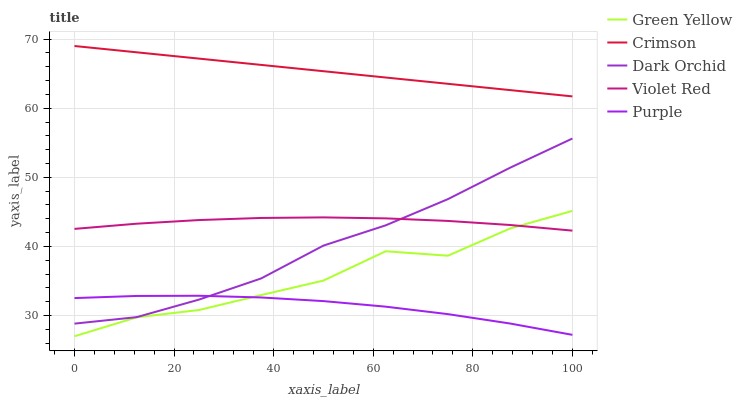Does Purple have the minimum area under the curve?
Answer yes or no. Yes. Does Violet Red have the minimum area under the curve?
Answer yes or no. No. Does Violet Red have the maximum area under the curve?
Answer yes or no. No. Is Green Yellow the roughest?
Answer yes or no. Yes. Is Purple the smoothest?
Answer yes or no. No. Is Purple the roughest?
Answer yes or no. No. Does Purple have the lowest value?
Answer yes or no. No. Does Violet Red have the highest value?
Answer yes or no. No. Is Green Yellow less than Crimson?
Answer yes or no. Yes. Is Crimson greater than Dark Orchid?
Answer yes or no. Yes. Does Green Yellow intersect Crimson?
Answer yes or no. No. 